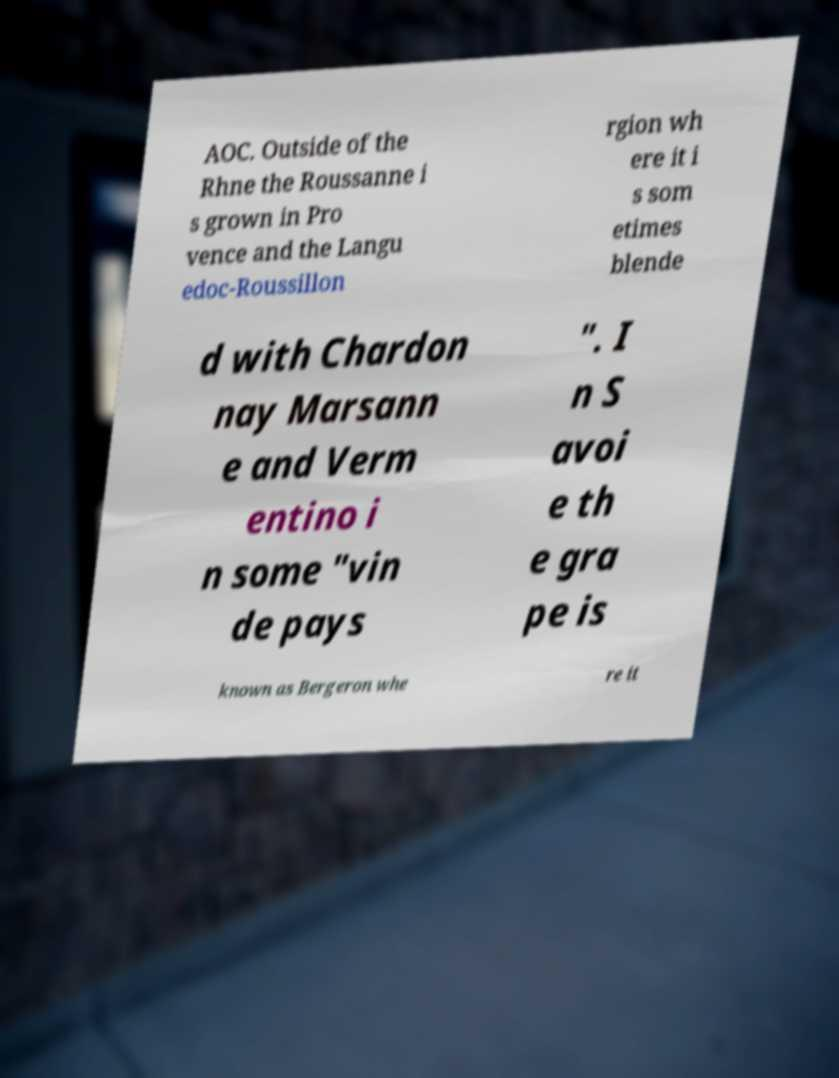Can you accurately transcribe the text from the provided image for me? AOC. Outside of the Rhne the Roussanne i s grown in Pro vence and the Langu edoc-Roussillon rgion wh ere it i s som etimes blende d with Chardon nay Marsann e and Verm entino i n some "vin de pays ". I n S avoi e th e gra pe is known as Bergeron whe re it 